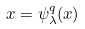Convert formula to latex. <formula><loc_0><loc_0><loc_500><loc_500>x = \psi _ { \lambda } ^ { q } ( x )</formula> 